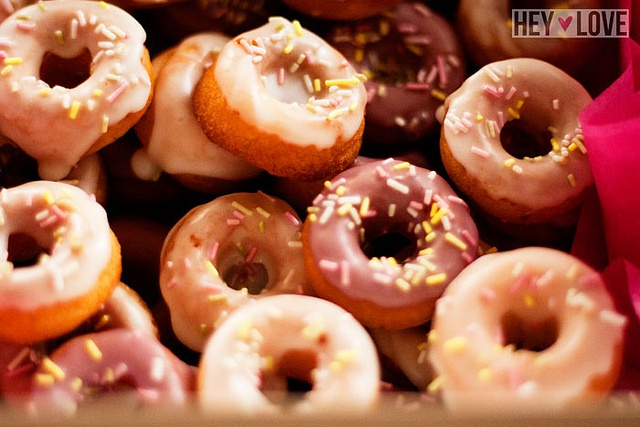Describe the objects in this image and their specific colors. I can see donut in salmon and tan tones, donut in salmon, brown, and black tones, donut in salmon, lightgray, tan, and brown tones, donut in salmon, ivory, tan, brown, and red tones, and donut in salmon, brown, maroon, and tan tones in this image. 